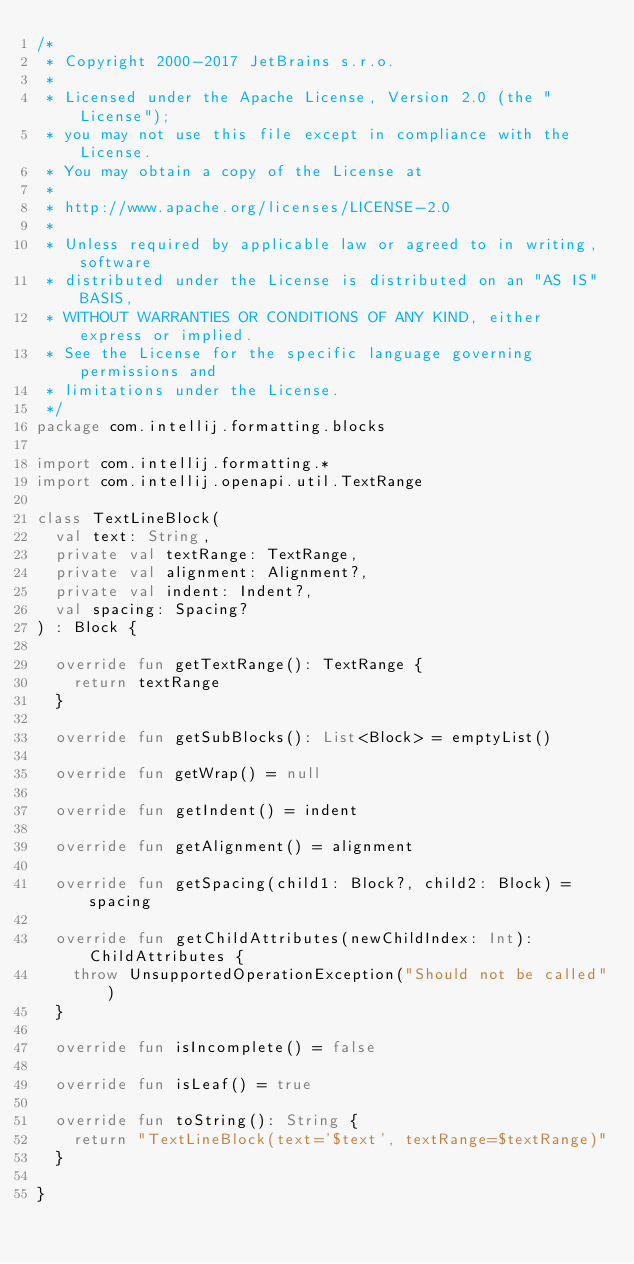<code> <loc_0><loc_0><loc_500><loc_500><_Kotlin_>/*
 * Copyright 2000-2017 JetBrains s.r.o.
 *
 * Licensed under the Apache License, Version 2.0 (the "License");
 * you may not use this file except in compliance with the License.
 * You may obtain a copy of the License at
 *
 * http://www.apache.org/licenses/LICENSE-2.0
 *
 * Unless required by applicable law or agreed to in writing, software
 * distributed under the License is distributed on an "AS IS" BASIS,
 * WITHOUT WARRANTIES OR CONDITIONS OF ANY KIND, either express or implied.
 * See the License for the specific language governing permissions and
 * limitations under the License.
 */
package com.intellij.formatting.blocks

import com.intellij.formatting.*
import com.intellij.openapi.util.TextRange

class TextLineBlock(
  val text: String,
  private val textRange: TextRange,
  private val alignment: Alignment?,
  private val indent: Indent?,
  val spacing: Spacing?
) : Block {

  override fun getTextRange(): TextRange {
    return textRange
  }

  override fun getSubBlocks(): List<Block> = emptyList()

  override fun getWrap() = null

  override fun getIndent() = indent

  override fun getAlignment() = alignment

  override fun getSpacing(child1: Block?, child2: Block) = spacing

  override fun getChildAttributes(newChildIndex: Int): ChildAttributes {
    throw UnsupportedOperationException("Should not be called")
  }

  override fun isIncomplete() = false

  override fun isLeaf() = true

  override fun toString(): String {
    return "TextLineBlock(text='$text', textRange=$textRange)"
  }

}
</code> 